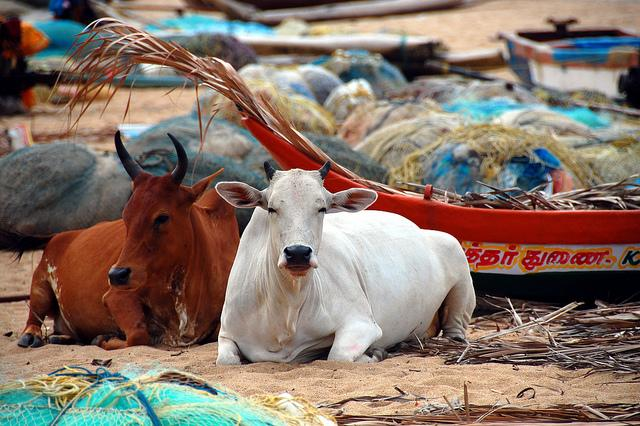What animal has similar things on their head to these animals? Please explain your reasoning. goat. Goats have horns, the other animals don't. 